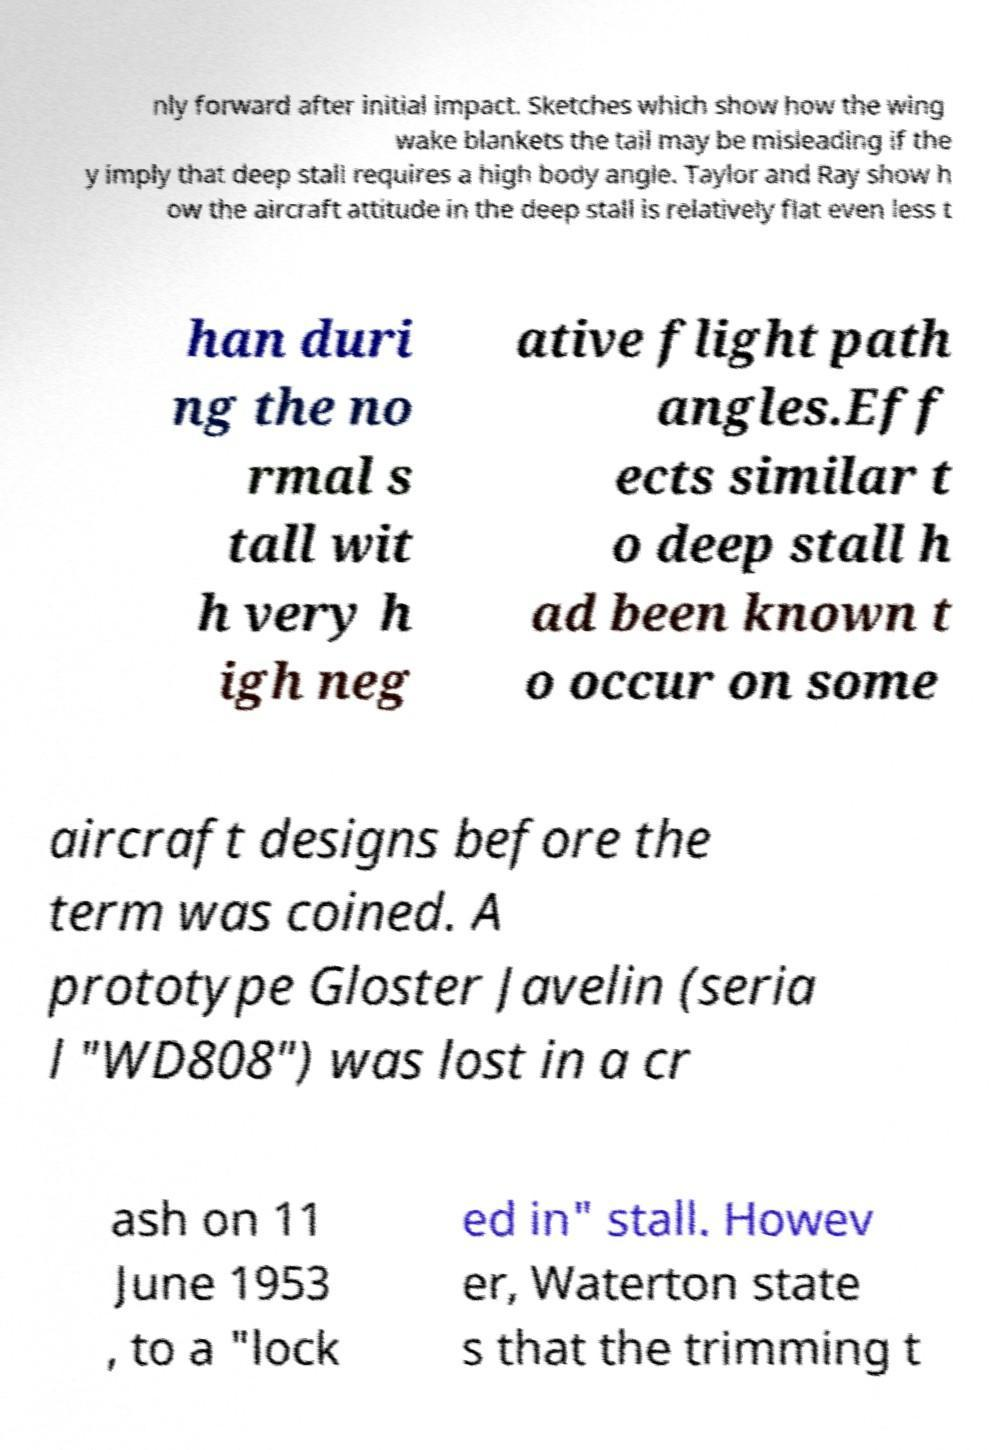What messages or text are displayed in this image? I need them in a readable, typed format. nly forward after initial impact. Sketches which show how the wing wake blankets the tail may be misleading if the y imply that deep stall requires a high body angle. Taylor and Ray show h ow the aircraft attitude in the deep stall is relatively flat even less t han duri ng the no rmal s tall wit h very h igh neg ative flight path angles.Eff ects similar t o deep stall h ad been known t o occur on some aircraft designs before the term was coined. A prototype Gloster Javelin (seria l "WD808") was lost in a cr ash on 11 June 1953 , to a "lock ed in" stall. Howev er, Waterton state s that the trimming t 